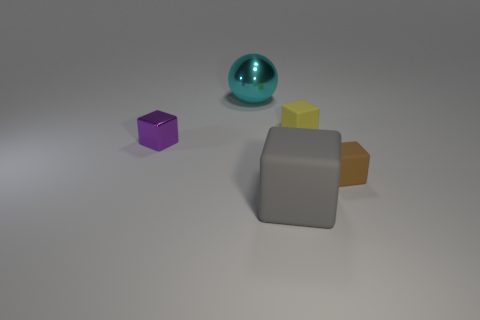Is there a small yellow rubber object of the same shape as the small brown rubber object?
Give a very brief answer. Yes. Is the number of tiny purple objects less than the number of blue cubes?
Provide a short and direct response. No. There is a matte cube that is on the left side of the yellow cube; does it have the same size as the object that is behind the small yellow rubber block?
Ensure brevity in your answer.  Yes. What number of objects are either balls or big blue matte cylinders?
Your response must be concise. 1. There is a shiny object that is on the left side of the large cyan object; what is its size?
Your answer should be very brief. Small. There is a small matte cube behind the small block to the left of the big gray thing; what number of objects are right of it?
Your response must be concise. 1. Is the small metallic cube the same color as the sphere?
Keep it short and to the point. No. How many things are on the right side of the tiny purple object and in front of the big cyan ball?
Make the answer very short. 3. The big gray thing that is in front of the brown rubber block has what shape?
Provide a succinct answer. Cube. Is the number of small purple cubes that are behind the tiny purple shiny block less than the number of cyan metallic things that are behind the tiny brown thing?
Keep it short and to the point. Yes. 